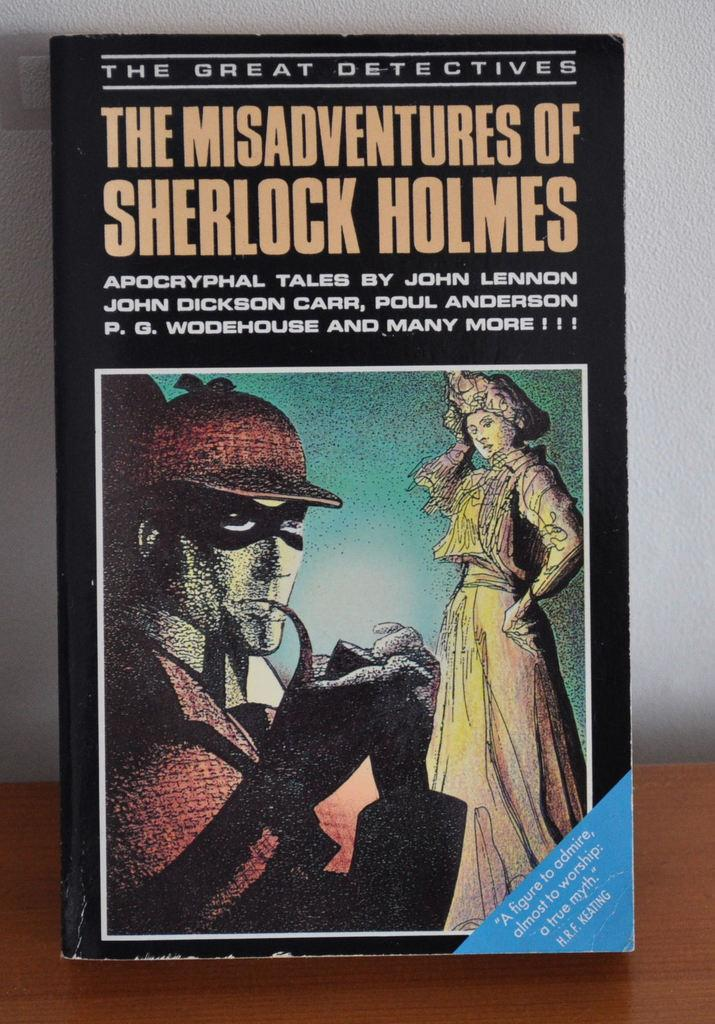<image>
Share a concise interpretation of the image provided. A book with multiple authors details the Misadventures of Sherlock Holmes. 